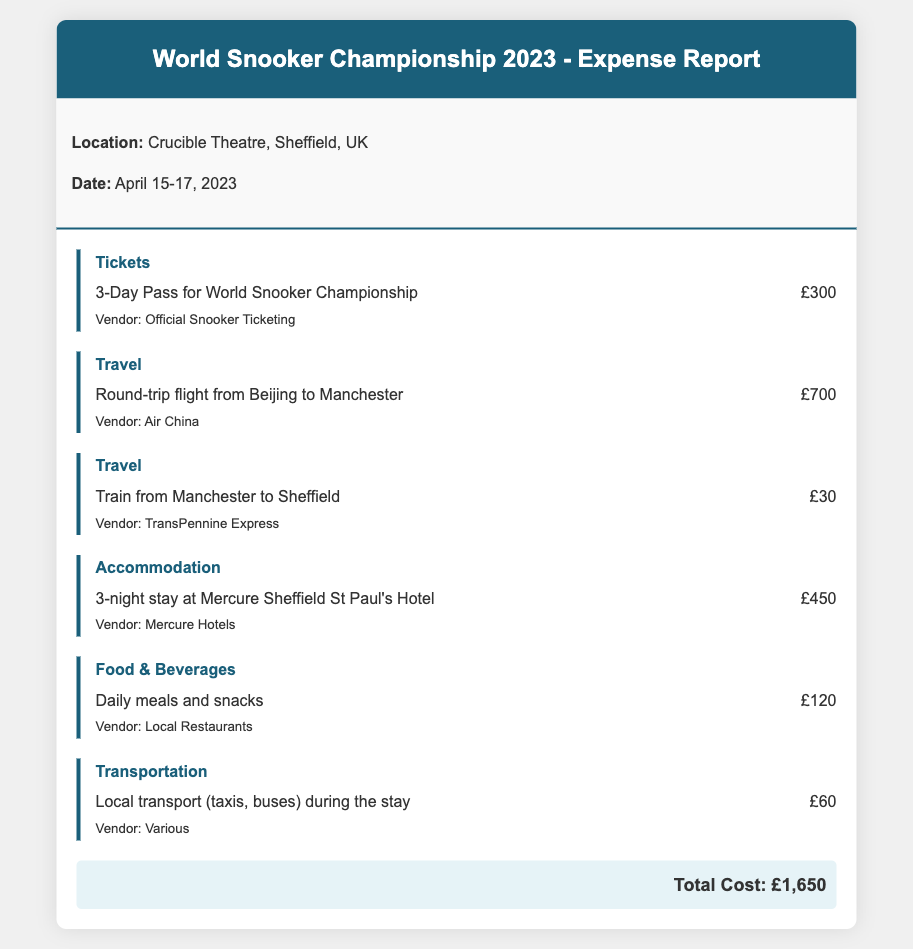What was the location of the event? The location of the event is mentioned in the event details of the document.
Answer: Crucible Theatre, Sheffield, UK How much was the 3-day pass ticket? The cost of the tickets is listed in the expense section of the document.
Answer: £300 What is the total cost of the trip? The total cost is provided at the end of the expense list in the document.
Answer: £1,650 How many nights did you stay at the hotel? The duration of the accommodation stay is specified in the accommodation expense item.
Answer: 3 nights What travel method was used from Manchester to Sheffield? The travel method used is mentioned in the travel expense section of the document.
Answer: Train What is the cost of local transport during the stay? The local transport cost is listed in the transportation expense item of the document.
Answer: £60 Which vendor provided the tickets? The vendor of the tickets is stated in the ticket expense section.
Answer: Official Snooker Ticketing What was the cost for food and beverages? The cost for food and beverages is detailed in the expense list.
Answer: £120 What type of hotel was booked for accommodation? The type of hotel is mentioned in the accommodation expense section.
Answer: Mercure Sheffield St Paul's Hotel 